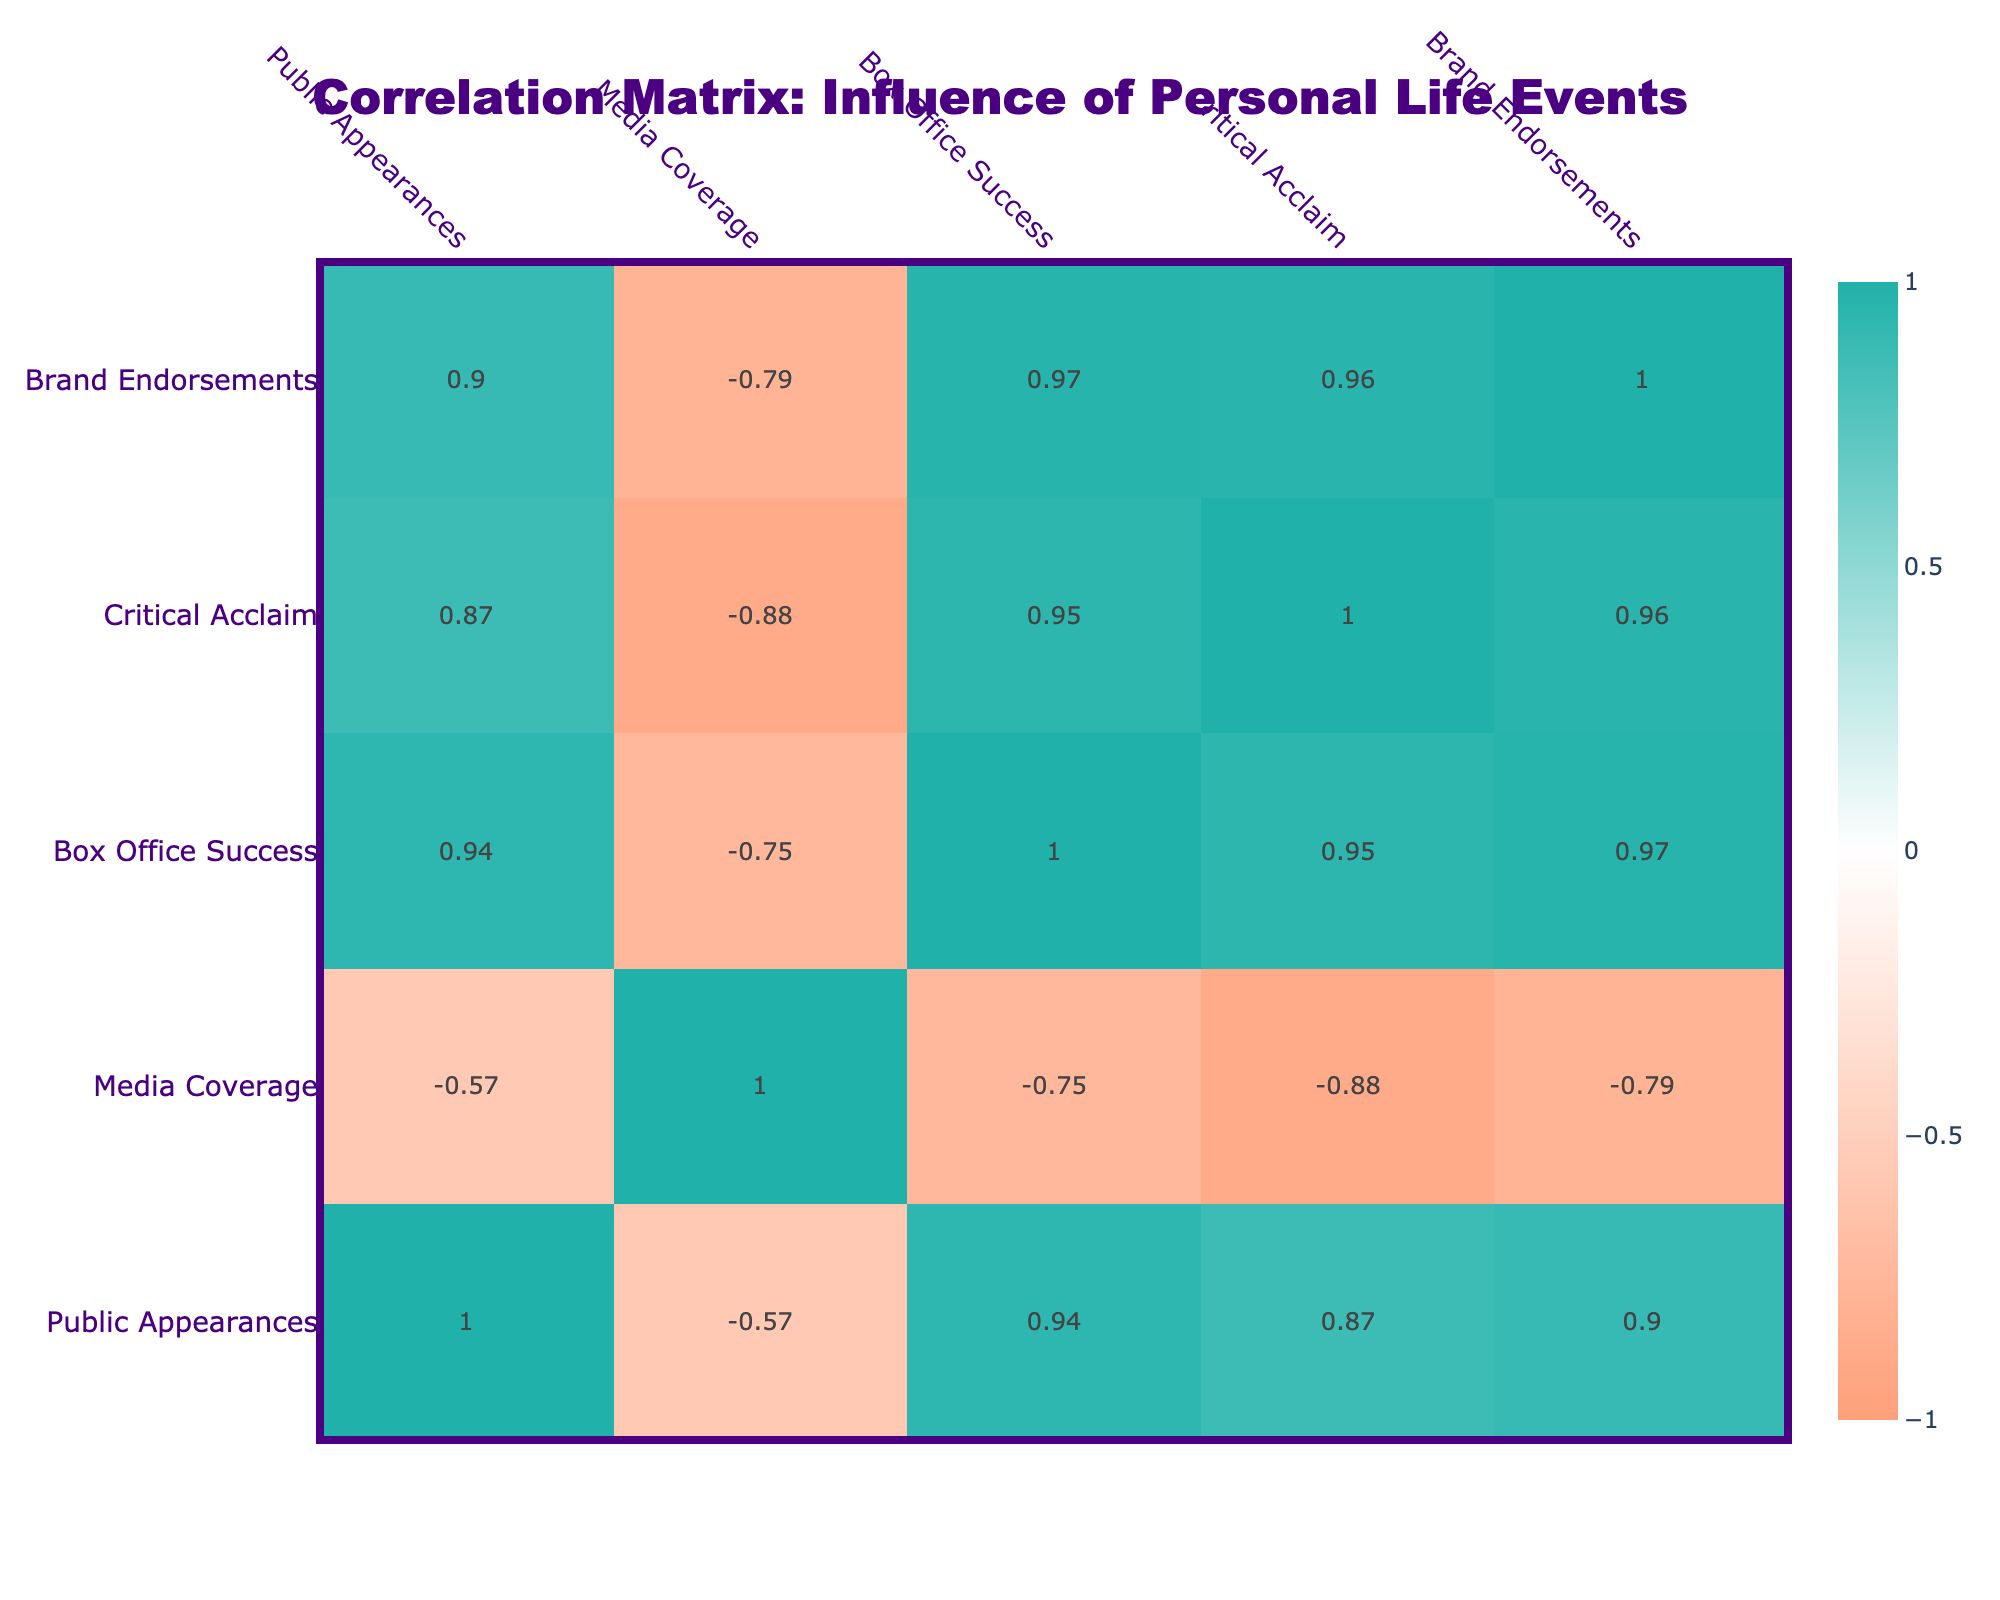What is the correlation between Public Appearances and Box Office Success? The correlation coefficient between Public Appearances and Box Office Success can be found by looking at the table. The value in the respective cell of the correlation matrix tells us the relationship strength. Upon checking, it is approximately 0.60, indicating a moderate positive correlation.
Answer: 0.60 Which event has the highest Media Coverage? By looking at the Media Coverage values in the table, I find that the event "Legal Troubles" has the highest Media Coverage at 100.
Answer: 100 Is it true that the Birth of a Child correlates more with Brand Endorsements than a New Relationship? To answer this, check the correlation coefficients for Birth of a Child (0.45) and New Relationship (0.40). Since 0.45 > 0.40, it is true that Birth of a Child has a higher correlation with Brand Endorsements than a New Relationship.
Answer: Yes What is the average Box Office Success for all events? I will sum up the Box Office Success values: 150 + 200 + 180 + 100 + 160 + 80 + 220 + 125 + 210 + 110 = 1,525. There are 10 events, so I will divide 1,525 by 10, which gives an average of 152.5.
Answer: 152.5 Which personal life event has the strongest influence on Critical Acclaim? To identify the strongest influence, I need to look for the highest correlation value in the Critical Acclaim column. The highest value I see is for "Winning an Award," which has a correlation of 0.90, indicating it has the strongest influence on Critical Acclaim.
Answer: Winning an Award How much more Box Office Success does a Comeback Film typically yield compared to Public Scandal? First, I find the Box Office Success for each event: Comeback Film is 210 and Public Scandal is 100. I calculate the difference: 210 - 100 = 110, showing that Comeback Films typically yield 110 more in Box Office Success compared to Public Scandals.
Answer: 110 Does Philanthropic Activity have a positive correlation with Brand Endorsements? Checking the correlation value for Philanthropic Activity and Brand Endorsements, which is around 0.35, indicates a positive correlation. Since it is greater than 0, it confirms that there is a positive relationship.
Answer: Yes What is the correlation between Legal Troubles and Public Appearances? Looking at the correlation matrix, I can see that the correlation coefficient for Legal Troubles and Public Appearances is approximately -0.60, indicating a moderate negative correlation between the two.
Answer: -0.60 